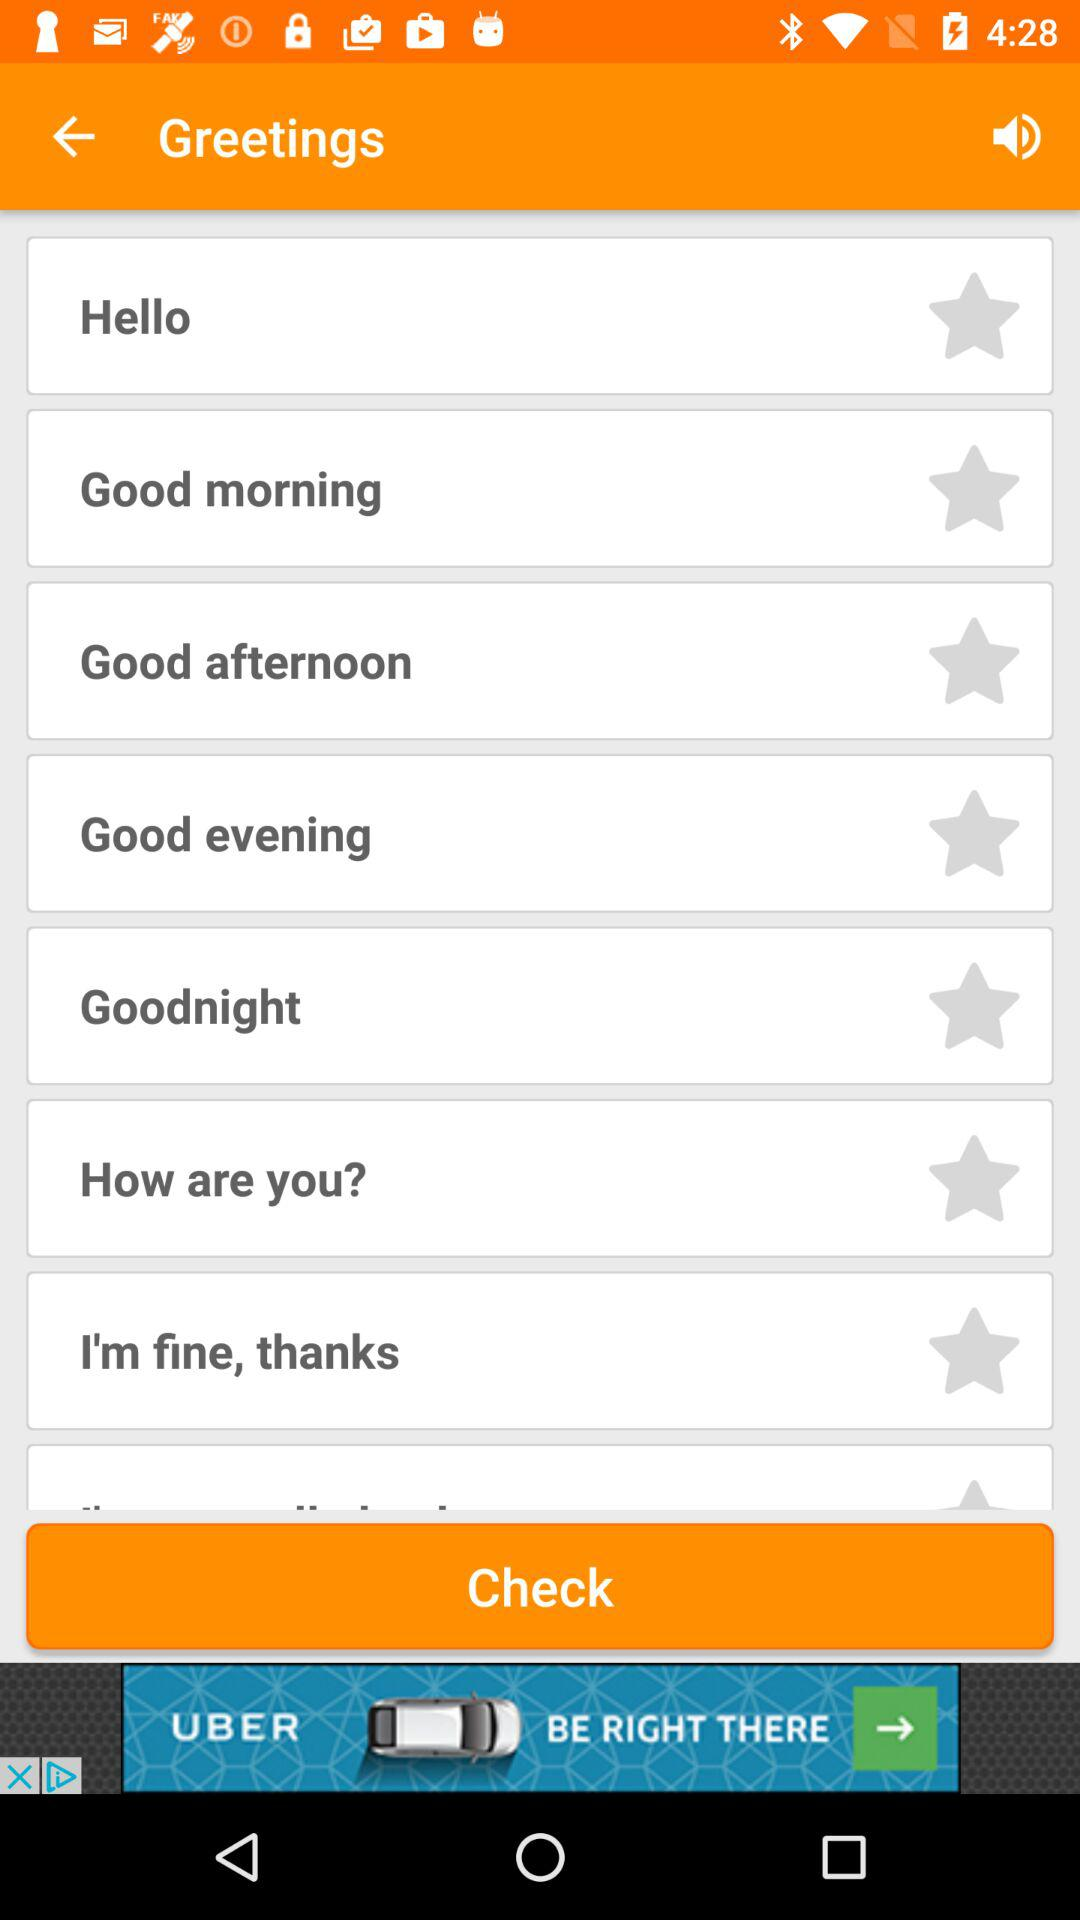How many greeting options are there?
Answer the question using a single word or phrase. 8 